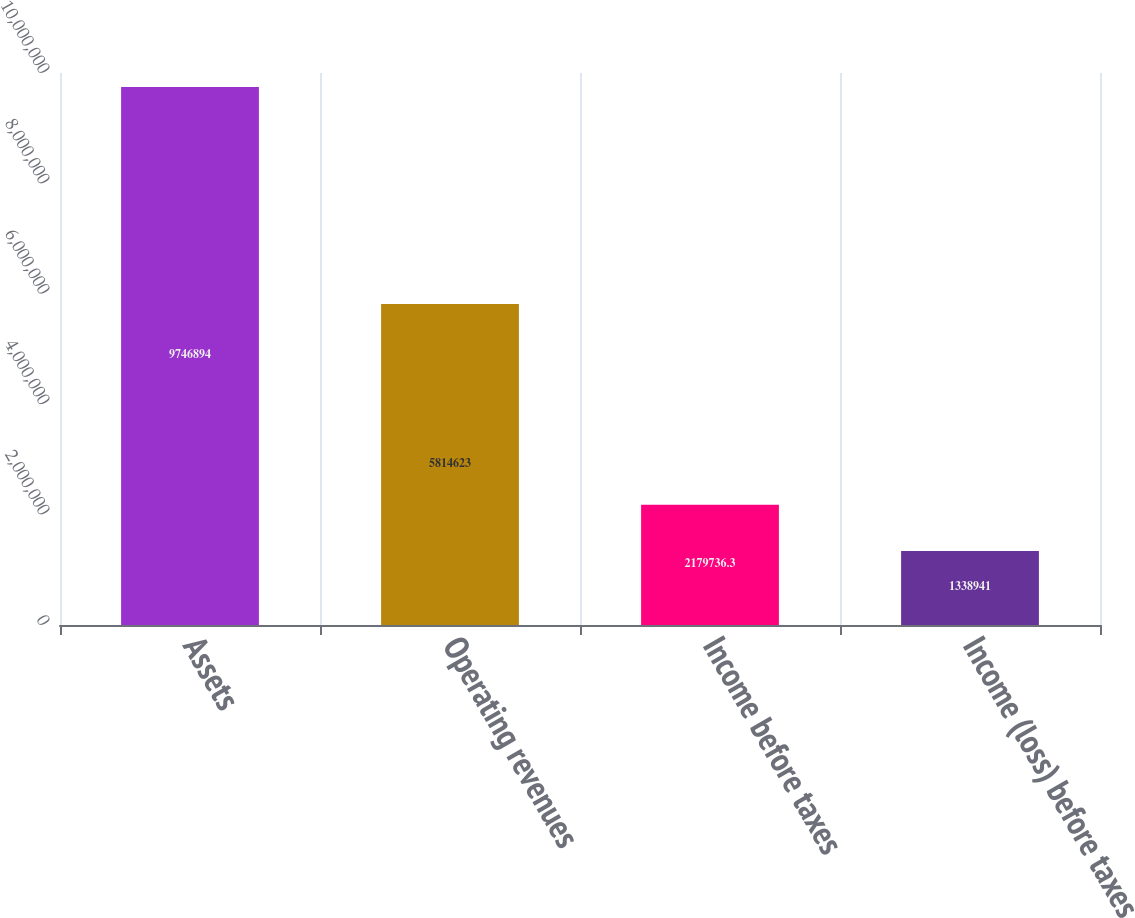Convert chart to OTSL. <chart><loc_0><loc_0><loc_500><loc_500><bar_chart><fcel>Assets<fcel>Operating revenues<fcel>Income before taxes<fcel>Income (loss) before taxes<nl><fcel>9.74689e+06<fcel>5.81462e+06<fcel>2.17974e+06<fcel>1.33894e+06<nl></chart> 